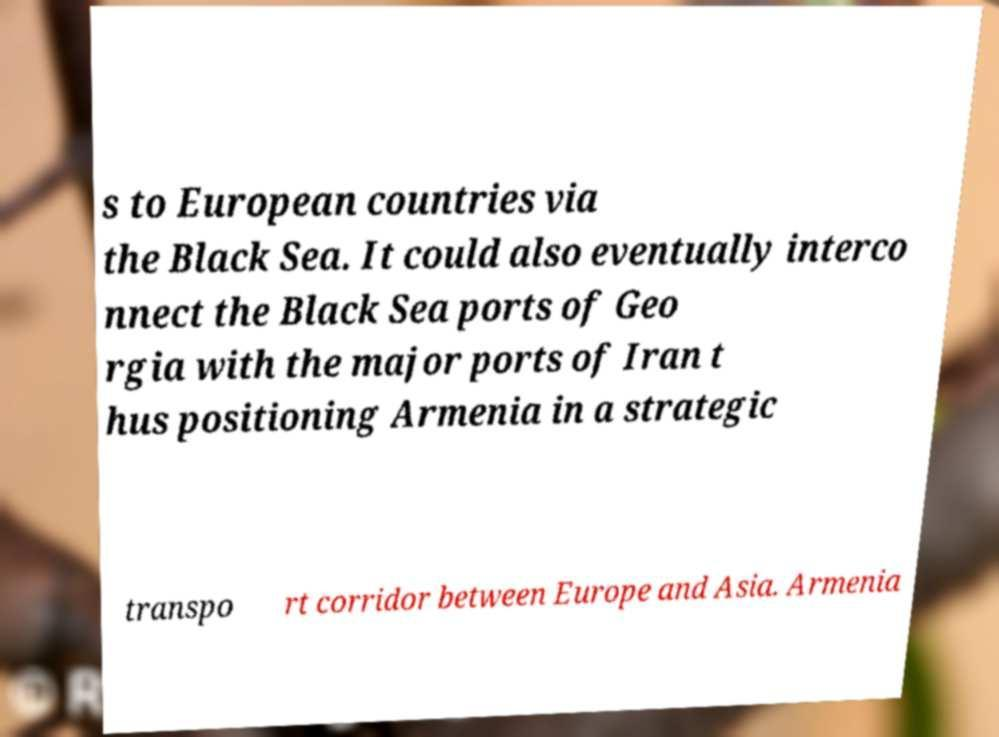Could you assist in decoding the text presented in this image and type it out clearly? s to European countries via the Black Sea. It could also eventually interco nnect the Black Sea ports of Geo rgia with the major ports of Iran t hus positioning Armenia in a strategic transpo rt corridor between Europe and Asia. Armenia 